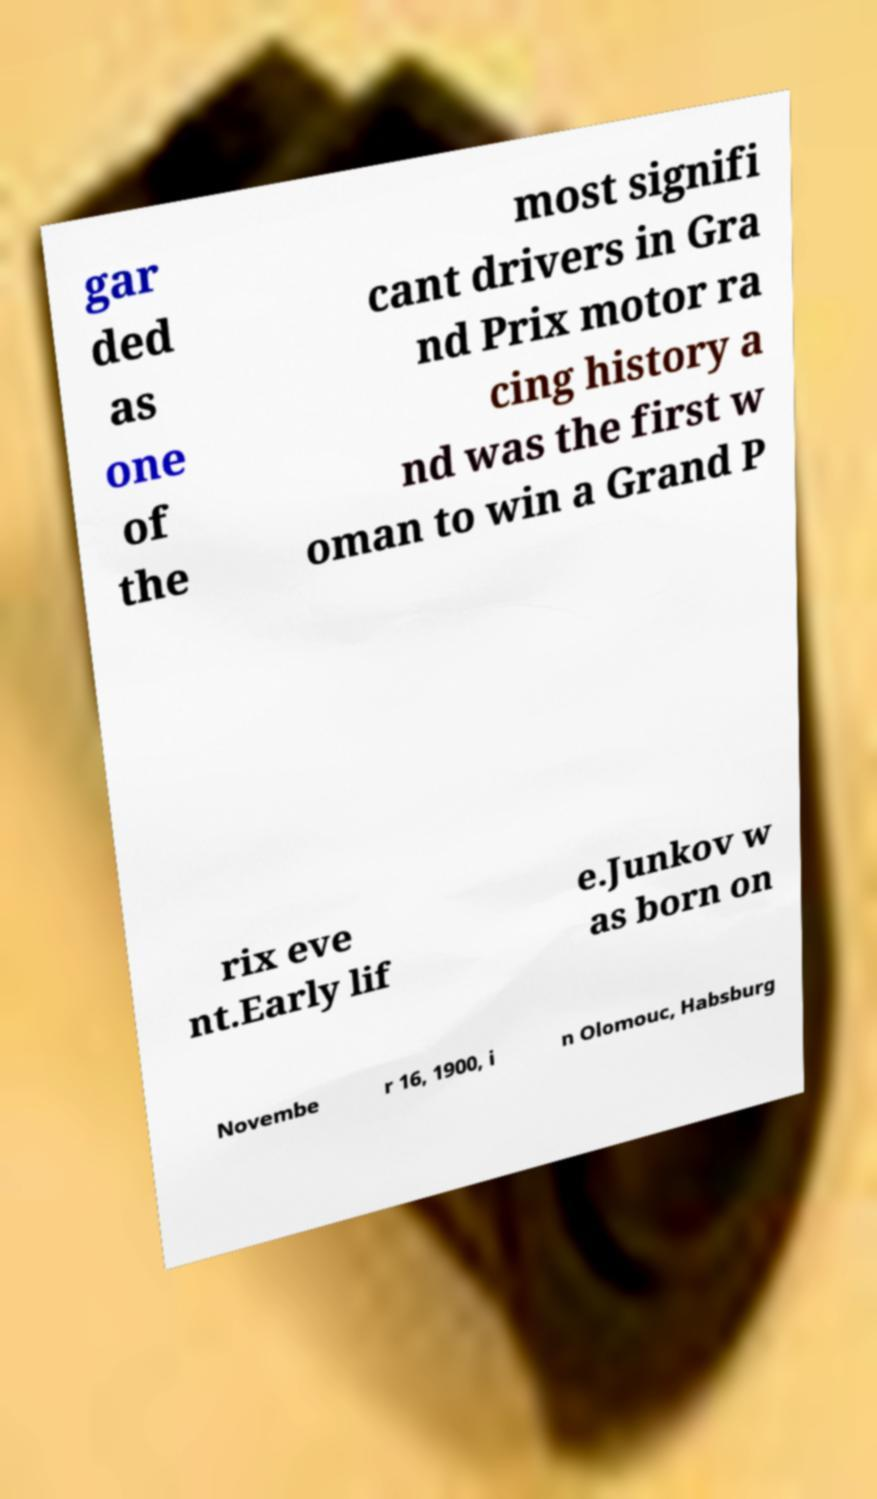There's text embedded in this image that I need extracted. Can you transcribe it verbatim? gar ded as one of the most signifi cant drivers in Gra nd Prix motor ra cing history a nd was the first w oman to win a Grand P rix eve nt.Early lif e.Junkov w as born on Novembe r 16, 1900, i n Olomouc, Habsburg 